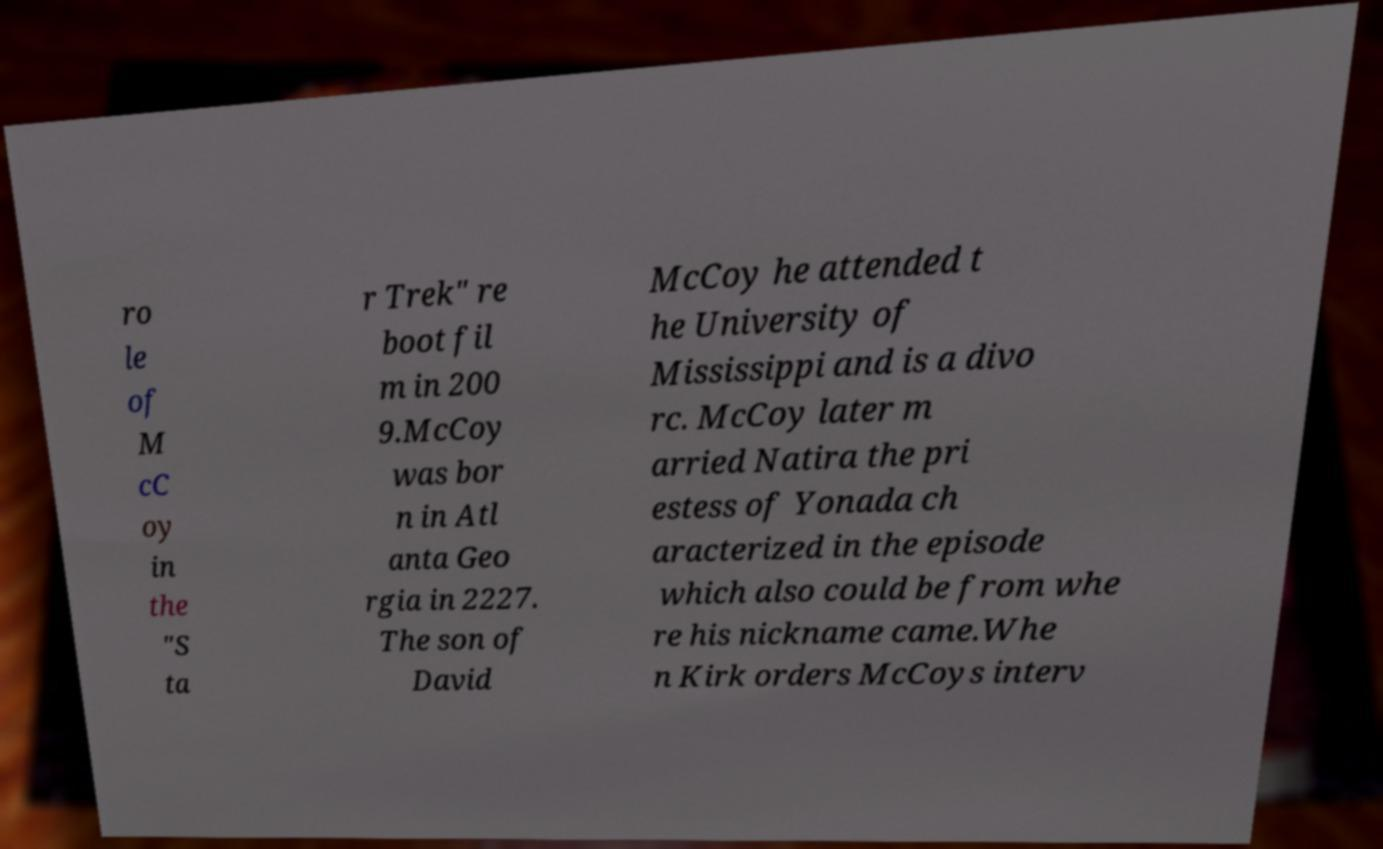Could you extract and type out the text from this image? ro le of M cC oy in the "S ta r Trek" re boot fil m in 200 9.McCoy was bor n in Atl anta Geo rgia in 2227. The son of David McCoy he attended t he University of Mississippi and is a divo rc. McCoy later m arried Natira the pri estess of Yonada ch aracterized in the episode which also could be from whe re his nickname came.Whe n Kirk orders McCoys interv 